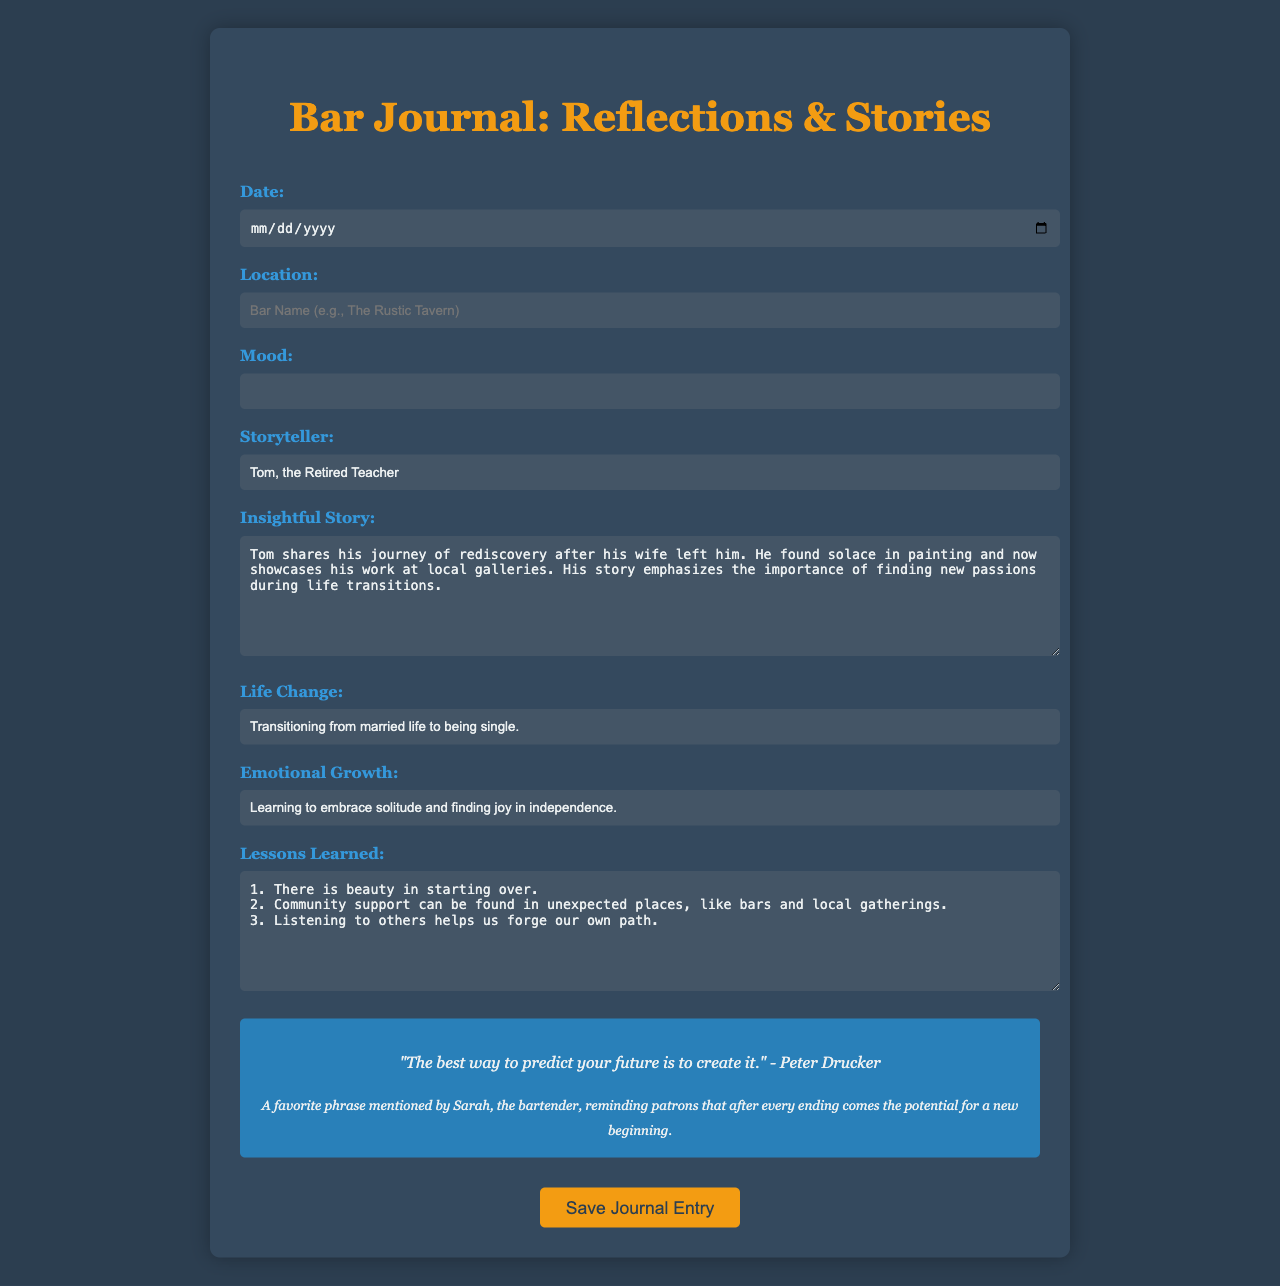What is the title of the journal? The title is presented prominently at the top of the document, introducing the purpose of the form.
Answer: Bar Journal: Reflections & Stories What is the required input for the mood? The mood field is mandatory and should specify the individual's emotional state during the visit.
Answer: Mood Who is the storyteller mentioned in the form? The storyteller's name is provided as part of the form, indicating who shared their story.
Answer: Tom, the Retired Teacher What is one main theme of the insightful story? The story highlighted in the form focuses on personal rediscovery and new passions after a significant life change.
Answer: Rediscovery What important lesson is emphasized in the lessons learned section? This section identifies key takeaways from the storyteller's experience, detailing insights that resonate with patrons.
Answer: There is beauty in starting over 